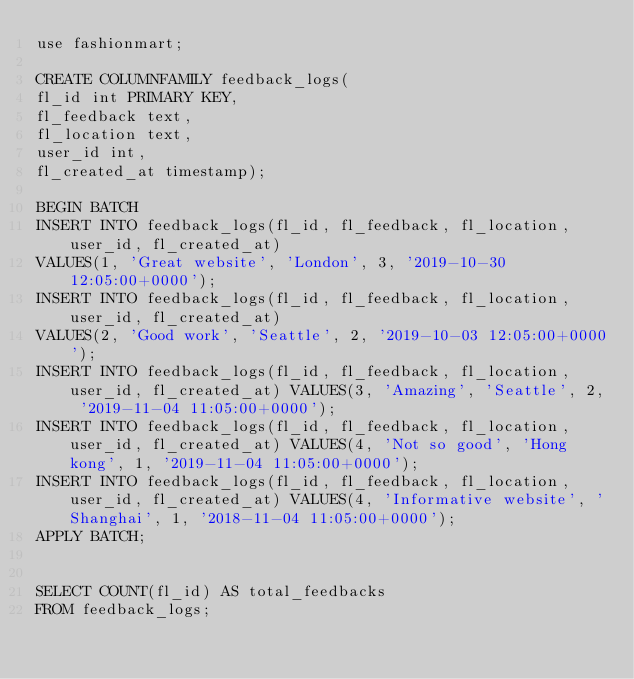<code> <loc_0><loc_0><loc_500><loc_500><_SQL_>use fashionmart;

CREATE COLUMNFAMILY feedback_logs(
fl_id int PRIMARY KEY,
fl_feedback text,
fl_location text,
user_id int,
fl_created_at timestamp);

BEGIN BATCH
INSERT INTO feedback_logs(fl_id, fl_feedback, fl_location, user_id, fl_created_at)
VALUES(1, 'Great website', 'London', 3, '2019-10-30 12:05:00+0000');
INSERT INTO feedback_logs(fl_id, fl_feedback, fl_location, user_id, fl_created_at)
VALUES(2, 'Good work', 'Seattle', 2, '2019-10-03 12:05:00+0000');
INSERT INTO feedback_logs(fl_id, fl_feedback, fl_location, user_id, fl_created_at) VALUES(3, 'Amazing', 'Seattle', 2, '2019-11-04 11:05:00+0000');
INSERT INTO feedback_logs(fl_id, fl_feedback, fl_location, user_id, fl_created_at) VALUES(4, 'Not so good', 'Hong kong', 1, '2019-11-04 11:05:00+0000');
INSERT INTO feedback_logs(fl_id, fl_feedback, fl_location, user_id, fl_created_at) VALUES(4, 'Informative website', 'Shanghai', 1, '2018-11-04 11:05:00+0000');
APPLY BATCH;


SELECT COUNT(fl_id) AS total_feedbacks
FROM feedback_logs;
</code> 